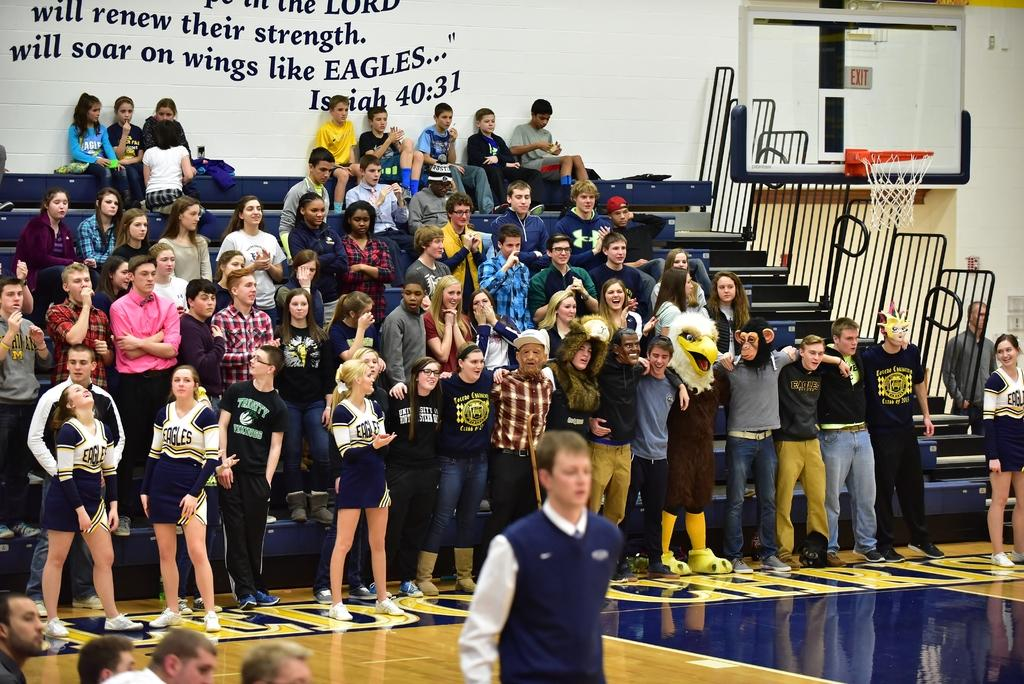<image>
Provide a brief description of the given image. The cheerleaders are wearing a uniform for the team Eagles 